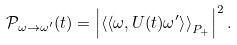<formula> <loc_0><loc_0><loc_500><loc_500>\mathcal { P } _ { \omega \rightarrow \omega ^ { \prime } } ( t ) = \left | \left \langle \left \langle \omega , U ( t ) \omega ^ { \prime } \right \rangle \right \rangle _ { P _ { + } } \right | ^ { 2 } .</formula> 